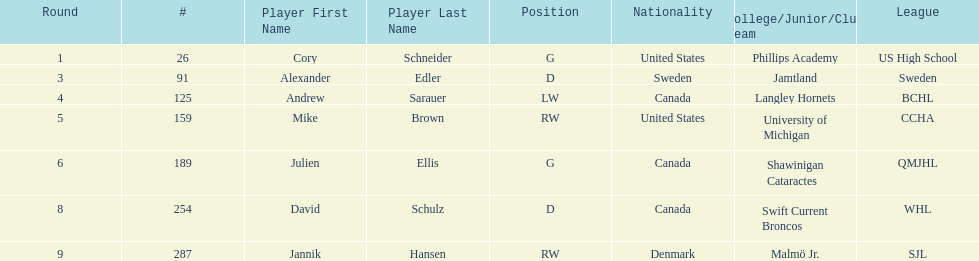Could you parse the entire table as a dict? {'header': ['Round', '#', 'Player First Name', 'Player Last Name', 'Position', 'Nationality', 'College/Junior/Club Team', 'League'], 'rows': [['1', '26', 'Cory', 'Schneider', 'G', 'United States', 'Phillips Academy', 'US High School'], ['3', '91', 'Alexander', 'Edler', 'D', 'Sweden', 'Jamtland', 'Sweden'], ['4', '125', 'Andrew', 'Sarauer', 'LW', 'Canada', 'Langley Hornets', 'BCHL'], ['5', '159', 'Mike', 'Brown', 'RW', 'United States', 'University of Michigan', 'CCHA'], ['6', '189', 'Julien', 'Ellis', 'G', 'Canada', 'Shawinigan Cataractes', 'QMJHL'], ['8', '254', 'David', 'Schulz', 'D', 'Canada', 'Swift Current Broncos', 'WHL'], ['9', '287', 'Jannik', 'Hansen', 'RW', 'Denmark', 'Malmö Jr.', 'SJL']]} Which player has canadian nationality and attended langley hornets? Andrew Sarauer (LW). 